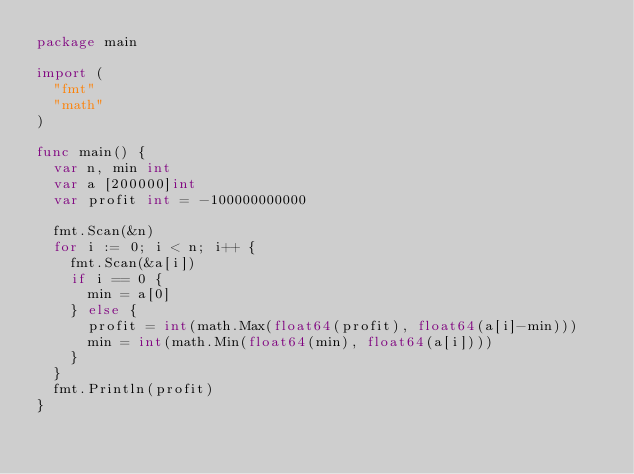<code> <loc_0><loc_0><loc_500><loc_500><_Go_>package main

import (
	"fmt"
	"math"
)

func main() {
	var n, min int
	var a [200000]int
	var profit int = -100000000000

	fmt.Scan(&n)
	for i := 0; i < n; i++ {
		fmt.Scan(&a[i])
		if i == 0 {
			min = a[0]
		} else {
			profit = int(math.Max(float64(profit), float64(a[i]-min)))
			min = int(math.Min(float64(min), float64(a[i])))
		}
	}
	fmt.Println(profit)
}

</code> 